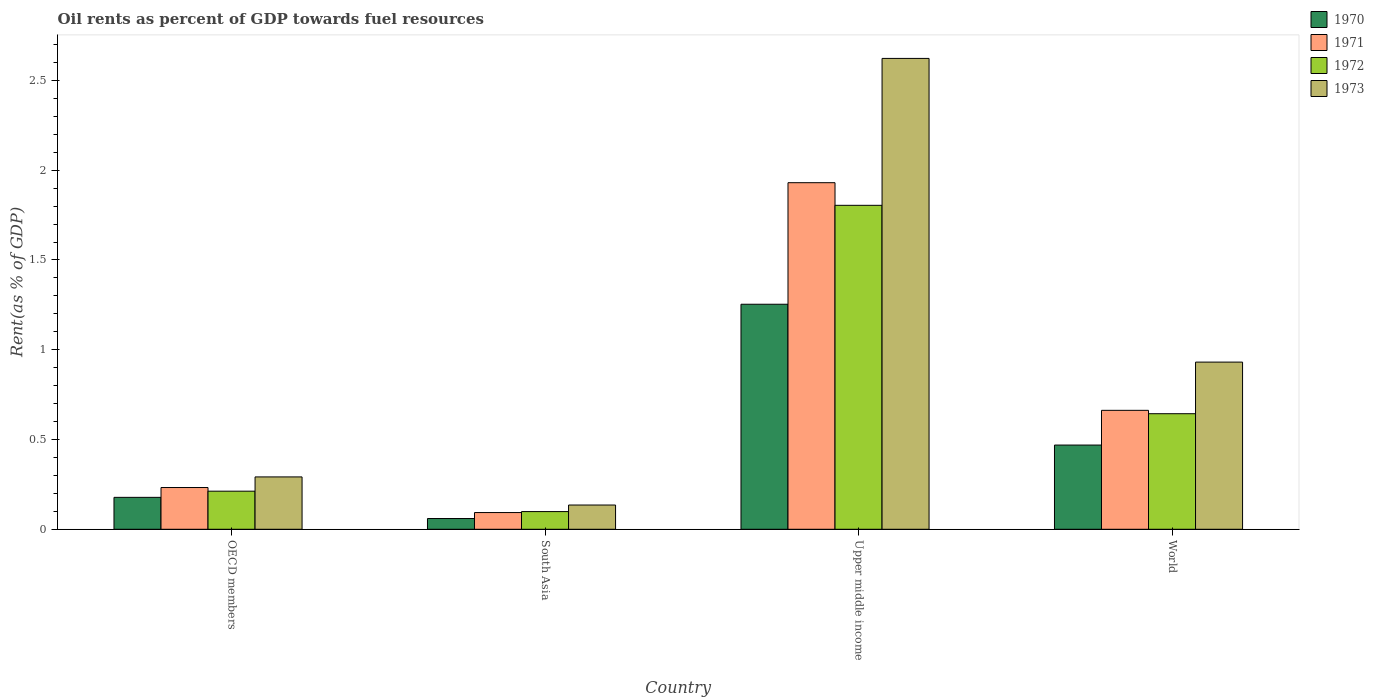How many different coloured bars are there?
Ensure brevity in your answer.  4. How many groups of bars are there?
Give a very brief answer. 4. In how many cases, is the number of bars for a given country not equal to the number of legend labels?
Give a very brief answer. 0. What is the oil rent in 1970 in Upper middle income?
Provide a succinct answer. 1.25. Across all countries, what is the maximum oil rent in 1973?
Ensure brevity in your answer.  2.62. Across all countries, what is the minimum oil rent in 1972?
Your answer should be very brief. 0.1. In which country was the oil rent in 1973 maximum?
Make the answer very short. Upper middle income. In which country was the oil rent in 1971 minimum?
Keep it short and to the point. South Asia. What is the total oil rent in 1973 in the graph?
Provide a short and direct response. 3.98. What is the difference between the oil rent in 1971 in OECD members and that in World?
Offer a very short reply. -0.43. What is the difference between the oil rent in 1973 in Upper middle income and the oil rent in 1971 in South Asia?
Offer a terse response. 2.53. What is the average oil rent in 1972 per country?
Your response must be concise. 0.69. What is the difference between the oil rent of/in 1971 and oil rent of/in 1972 in OECD members?
Make the answer very short. 0.02. What is the ratio of the oil rent in 1972 in OECD members to that in Upper middle income?
Ensure brevity in your answer.  0.12. What is the difference between the highest and the second highest oil rent in 1970?
Your response must be concise. -0.78. What is the difference between the highest and the lowest oil rent in 1970?
Your answer should be very brief. 1.19. In how many countries, is the oil rent in 1972 greater than the average oil rent in 1972 taken over all countries?
Ensure brevity in your answer.  1. What does the 2nd bar from the left in Upper middle income represents?
Provide a succinct answer. 1971. Is it the case that in every country, the sum of the oil rent in 1972 and oil rent in 1971 is greater than the oil rent in 1970?
Your response must be concise. Yes. Are all the bars in the graph horizontal?
Your answer should be compact. No. What is the difference between two consecutive major ticks on the Y-axis?
Provide a succinct answer. 0.5. Does the graph contain grids?
Your response must be concise. No. How many legend labels are there?
Offer a very short reply. 4. How are the legend labels stacked?
Your response must be concise. Vertical. What is the title of the graph?
Your answer should be very brief. Oil rents as percent of GDP towards fuel resources. What is the label or title of the Y-axis?
Make the answer very short. Rent(as % of GDP). What is the Rent(as % of GDP) in 1970 in OECD members?
Make the answer very short. 0.18. What is the Rent(as % of GDP) of 1971 in OECD members?
Offer a terse response. 0.23. What is the Rent(as % of GDP) of 1972 in OECD members?
Make the answer very short. 0.21. What is the Rent(as % of GDP) in 1973 in OECD members?
Give a very brief answer. 0.29. What is the Rent(as % of GDP) in 1970 in South Asia?
Make the answer very short. 0.06. What is the Rent(as % of GDP) of 1971 in South Asia?
Your answer should be very brief. 0.09. What is the Rent(as % of GDP) of 1972 in South Asia?
Your answer should be compact. 0.1. What is the Rent(as % of GDP) in 1973 in South Asia?
Your answer should be very brief. 0.14. What is the Rent(as % of GDP) in 1970 in Upper middle income?
Offer a very short reply. 1.25. What is the Rent(as % of GDP) in 1971 in Upper middle income?
Ensure brevity in your answer.  1.93. What is the Rent(as % of GDP) in 1972 in Upper middle income?
Provide a short and direct response. 1.8. What is the Rent(as % of GDP) in 1973 in Upper middle income?
Make the answer very short. 2.62. What is the Rent(as % of GDP) of 1970 in World?
Provide a succinct answer. 0.47. What is the Rent(as % of GDP) of 1971 in World?
Offer a very short reply. 0.66. What is the Rent(as % of GDP) of 1972 in World?
Offer a very short reply. 0.64. What is the Rent(as % of GDP) in 1973 in World?
Keep it short and to the point. 0.93. Across all countries, what is the maximum Rent(as % of GDP) in 1970?
Provide a short and direct response. 1.25. Across all countries, what is the maximum Rent(as % of GDP) of 1971?
Your answer should be compact. 1.93. Across all countries, what is the maximum Rent(as % of GDP) in 1972?
Offer a very short reply. 1.8. Across all countries, what is the maximum Rent(as % of GDP) in 1973?
Provide a succinct answer. 2.62. Across all countries, what is the minimum Rent(as % of GDP) of 1970?
Offer a terse response. 0.06. Across all countries, what is the minimum Rent(as % of GDP) in 1971?
Provide a short and direct response. 0.09. Across all countries, what is the minimum Rent(as % of GDP) of 1972?
Keep it short and to the point. 0.1. Across all countries, what is the minimum Rent(as % of GDP) of 1973?
Offer a terse response. 0.14. What is the total Rent(as % of GDP) in 1970 in the graph?
Give a very brief answer. 1.96. What is the total Rent(as % of GDP) of 1971 in the graph?
Keep it short and to the point. 2.92. What is the total Rent(as % of GDP) in 1972 in the graph?
Make the answer very short. 2.76. What is the total Rent(as % of GDP) of 1973 in the graph?
Give a very brief answer. 3.98. What is the difference between the Rent(as % of GDP) in 1970 in OECD members and that in South Asia?
Provide a short and direct response. 0.12. What is the difference between the Rent(as % of GDP) of 1971 in OECD members and that in South Asia?
Keep it short and to the point. 0.14. What is the difference between the Rent(as % of GDP) in 1972 in OECD members and that in South Asia?
Your response must be concise. 0.11. What is the difference between the Rent(as % of GDP) in 1973 in OECD members and that in South Asia?
Offer a terse response. 0.16. What is the difference between the Rent(as % of GDP) in 1970 in OECD members and that in Upper middle income?
Keep it short and to the point. -1.08. What is the difference between the Rent(as % of GDP) of 1971 in OECD members and that in Upper middle income?
Provide a succinct answer. -1.7. What is the difference between the Rent(as % of GDP) in 1972 in OECD members and that in Upper middle income?
Your answer should be very brief. -1.59. What is the difference between the Rent(as % of GDP) of 1973 in OECD members and that in Upper middle income?
Ensure brevity in your answer.  -2.33. What is the difference between the Rent(as % of GDP) in 1970 in OECD members and that in World?
Ensure brevity in your answer.  -0.29. What is the difference between the Rent(as % of GDP) of 1971 in OECD members and that in World?
Give a very brief answer. -0.43. What is the difference between the Rent(as % of GDP) of 1972 in OECD members and that in World?
Your answer should be compact. -0.43. What is the difference between the Rent(as % of GDP) in 1973 in OECD members and that in World?
Provide a short and direct response. -0.64. What is the difference between the Rent(as % of GDP) of 1970 in South Asia and that in Upper middle income?
Give a very brief answer. -1.19. What is the difference between the Rent(as % of GDP) in 1971 in South Asia and that in Upper middle income?
Your answer should be very brief. -1.84. What is the difference between the Rent(as % of GDP) of 1972 in South Asia and that in Upper middle income?
Make the answer very short. -1.71. What is the difference between the Rent(as % of GDP) in 1973 in South Asia and that in Upper middle income?
Keep it short and to the point. -2.49. What is the difference between the Rent(as % of GDP) of 1970 in South Asia and that in World?
Keep it short and to the point. -0.41. What is the difference between the Rent(as % of GDP) in 1971 in South Asia and that in World?
Give a very brief answer. -0.57. What is the difference between the Rent(as % of GDP) in 1972 in South Asia and that in World?
Provide a short and direct response. -0.55. What is the difference between the Rent(as % of GDP) of 1973 in South Asia and that in World?
Offer a terse response. -0.8. What is the difference between the Rent(as % of GDP) of 1970 in Upper middle income and that in World?
Your response must be concise. 0.78. What is the difference between the Rent(as % of GDP) of 1971 in Upper middle income and that in World?
Offer a very short reply. 1.27. What is the difference between the Rent(as % of GDP) in 1972 in Upper middle income and that in World?
Your response must be concise. 1.16. What is the difference between the Rent(as % of GDP) of 1973 in Upper middle income and that in World?
Provide a short and direct response. 1.69. What is the difference between the Rent(as % of GDP) in 1970 in OECD members and the Rent(as % of GDP) in 1971 in South Asia?
Give a very brief answer. 0.08. What is the difference between the Rent(as % of GDP) in 1970 in OECD members and the Rent(as % of GDP) in 1972 in South Asia?
Your answer should be compact. 0.08. What is the difference between the Rent(as % of GDP) in 1970 in OECD members and the Rent(as % of GDP) in 1973 in South Asia?
Ensure brevity in your answer.  0.04. What is the difference between the Rent(as % of GDP) of 1971 in OECD members and the Rent(as % of GDP) of 1972 in South Asia?
Provide a succinct answer. 0.13. What is the difference between the Rent(as % of GDP) of 1971 in OECD members and the Rent(as % of GDP) of 1973 in South Asia?
Provide a succinct answer. 0.1. What is the difference between the Rent(as % of GDP) of 1972 in OECD members and the Rent(as % of GDP) of 1973 in South Asia?
Keep it short and to the point. 0.08. What is the difference between the Rent(as % of GDP) in 1970 in OECD members and the Rent(as % of GDP) in 1971 in Upper middle income?
Provide a succinct answer. -1.75. What is the difference between the Rent(as % of GDP) in 1970 in OECD members and the Rent(as % of GDP) in 1972 in Upper middle income?
Provide a succinct answer. -1.63. What is the difference between the Rent(as % of GDP) in 1970 in OECD members and the Rent(as % of GDP) in 1973 in Upper middle income?
Your response must be concise. -2.44. What is the difference between the Rent(as % of GDP) of 1971 in OECD members and the Rent(as % of GDP) of 1972 in Upper middle income?
Your response must be concise. -1.57. What is the difference between the Rent(as % of GDP) of 1971 in OECD members and the Rent(as % of GDP) of 1973 in Upper middle income?
Keep it short and to the point. -2.39. What is the difference between the Rent(as % of GDP) in 1972 in OECD members and the Rent(as % of GDP) in 1973 in Upper middle income?
Provide a short and direct response. -2.41. What is the difference between the Rent(as % of GDP) of 1970 in OECD members and the Rent(as % of GDP) of 1971 in World?
Your response must be concise. -0.48. What is the difference between the Rent(as % of GDP) in 1970 in OECD members and the Rent(as % of GDP) in 1972 in World?
Keep it short and to the point. -0.47. What is the difference between the Rent(as % of GDP) of 1970 in OECD members and the Rent(as % of GDP) of 1973 in World?
Offer a very short reply. -0.75. What is the difference between the Rent(as % of GDP) in 1971 in OECD members and the Rent(as % of GDP) in 1972 in World?
Give a very brief answer. -0.41. What is the difference between the Rent(as % of GDP) of 1971 in OECD members and the Rent(as % of GDP) of 1973 in World?
Ensure brevity in your answer.  -0.7. What is the difference between the Rent(as % of GDP) of 1972 in OECD members and the Rent(as % of GDP) of 1973 in World?
Provide a short and direct response. -0.72. What is the difference between the Rent(as % of GDP) of 1970 in South Asia and the Rent(as % of GDP) of 1971 in Upper middle income?
Your answer should be very brief. -1.87. What is the difference between the Rent(as % of GDP) of 1970 in South Asia and the Rent(as % of GDP) of 1972 in Upper middle income?
Keep it short and to the point. -1.74. What is the difference between the Rent(as % of GDP) of 1970 in South Asia and the Rent(as % of GDP) of 1973 in Upper middle income?
Make the answer very short. -2.56. What is the difference between the Rent(as % of GDP) of 1971 in South Asia and the Rent(as % of GDP) of 1972 in Upper middle income?
Your answer should be very brief. -1.71. What is the difference between the Rent(as % of GDP) in 1971 in South Asia and the Rent(as % of GDP) in 1973 in Upper middle income?
Offer a very short reply. -2.53. What is the difference between the Rent(as % of GDP) in 1972 in South Asia and the Rent(as % of GDP) in 1973 in Upper middle income?
Your answer should be very brief. -2.52. What is the difference between the Rent(as % of GDP) in 1970 in South Asia and the Rent(as % of GDP) in 1971 in World?
Your answer should be compact. -0.6. What is the difference between the Rent(as % of GDP) in 1970 in South Asia and the Rent(as % of GDP) in 1972 in World?
Ensure brevity in your answer.  -0.58. What is the difference between the Rent(as % of GDP) of 1970 in South Asia and the Rent(as % of GDP) of 1973 in World?
Your answer should be very brief. -0.87. What is the difference between the Rent(as % of GDP) in 1971 in South Asia and the Rent(as % of GDP) in 1972 in World?
Your answer should be very brief. -0.55. What is the difference between the Rent(as % of GDP) of 1971 in South Asia and the Rent(as % of GDP) of 1973 in World?
Make the answer very short. -0.84. What is the difference between the Rent(as % of GDP) in 1972 in South Asia and the Rent(as % of GDP) in 1973 in World?
Provide a short and direct response. -0.83. What is the difference between the Rent(as % of GDP) in 1970 in Upper middle income and the Rent(as % of GDP) in 1971 in World?
Your answer should be very brief. 0.59. What is the difference between the Rent(as % of GDP) of 1970 in Upper middle income and the Rent(as % of GDP) of 1972 in World?
Provide a succinct answer. 0.61. What is the difference between the Rent(as % of GDP) in 1970 in Upper middle income and the Rent(as % of GDP) in 1973 in World?
Provide a short and direct response. 0.32. What is the difference between the Rent(as % of GDP) of 1971 in Upper middle income and the Rent(as % of GDP) of 1972 in World?
Give a very brief answer. 1.29. What is the difference between the Rent(as % of GDP) of 1971 in Upper middle income and the Rent(as % of GDP) of 1973 in World?
Provide a succinct answer. 1. What is the difference between the Rent(as % of GDP) of 1972 in Upper middle income and the Rent(as % of GDP) of 1973 in World?
Keep it short and to the point. 0.87. What is the average Rent(as % of GDP) of 1970 per country?
Provide a short and direct response. 0.49. What is the average Rent(as % of GDP) of 1971 per country?
Offer a very short reply. 0.73. What is the average Rent(as % of GDP) in 1972 per country?
Offer a very short reply. 0.69. What is the difference between the Rent(as % of GDP) of 1970 and Rent(as % of GDP) of 1971 in OECD members?
Offer a terse response. -0.05. What is the difference between the Rent(as % of GDP) in 1970 and Rent(as % of GDP) in 1972 in OECD members?
Your answer should be very brief. -0.03. What is the difference between the Rent(as % of GDP) in 1970 and Rent(as % of GDP) in 1973 in OECD members?
Provide a short and direct response. -0.11. What is the difference between the Rent(as % of GDP) of 1971 and Rent(as % of GDP) of 1972 in OECD members?
Provide a succinct answer. 0.02. What is the difference between the Rent(as % of GDP) of 1971 and Rent(as % of GDP) of 1973 in OECD members?
Provide a short and direct response. -0.06. What is the difference between the Rent(as % of GDP) in 1972 and Rent(as % of GDP) in 1973 in OECD members?
Ensure brevity in your answer.  -0.08. What is the difference between the Rent(as % of GDP) in 1970 and Rent(as % of GDP) in 1971 in South Asia?
Offer a very short reply. -0.03. What is the difference between the Rent(as % of GDP) of 1970 and Rent(as % of GDP) of 1972 in South Asia?
Provide a succinct answer. -0.04. What is the difference between the Rent(as % of GDP) of 1970 and Rent(as % of GDP) of 1973 in South Asia?
Ensure brevity in your answer.  -0.08. What is the difference between the Rent(as % of GDP) in 1971 and Rent(as % of GDP) in 1972 in South Asia?
Offer a very short reply. -0.01. What is the difference between the Rent(as % of GDP) of 1971 and Rent(as % of GDP) of 1973 in South Asia?
Your response must be concise. -0.04. What is the difference between the Rent(as % of GDP) of 1972 and Rent(as % of GDP) of 1973 in South Asia?
Offer a terse response. -0.04. What is the difference between the Rent(as % of GDP) in 1970 and Rent(as % of GDP) in 1971 in Upper middle income?
Your response must be concise. -0.68. What is the difference between the Rent(as % of GDP) in 1970 and Rent(as % of GDP) in 1972 in Upper middle income?
Ensure brevity in your answer.  -0.55. What is the difference between the Rent(as % of GDP) of 1970 and Rent(as % of GDP) of 1973 in Upper middle income?
Make the answer very short. -1.37. What is the difference between the Rent(as % of GDP) in 1971 and Rent(as % of GDP) in 1972 in Upper middle income?
Provide a short and direct response. 0.13. What is the difference between the Rent(as % of GDP) of 1971 and Rent(as % of GDP) of 1973 in Upper middle income?
Offer a terse response. -0.69. What is the difference between the Rent(as % of GDP) of 1972 and Rent(as % of GDP) of 1973 in Upper middle income?
Give a very brief answer. -0.82. What is the difference between the Rent(as % of GDP) in 1970 and Rent(as % of GDP) in 1971 in World?
Your response must be concise. -0.19. What is the difference between the Rent(as % of GDP) in 1970 and Rent(as % of GDP) in 1972 in World?
Your answer should be compact. -0.17. What is the difference between the Rent(as % of GDP) in 1970 and Rent(as % of GDP) in 1973 in World?
Ensure brevity in your answer.  -0.46. What is the difference between the Rent(as % of GDP) of 1971 and Rent(as % of GDP) of 1972 in World?
Keep it short and to the point. 0.02. What is the difference between the Rent(as % of GDP) in 1971 and Rent(as % of GDP) in 1973 in World?
Give a very brief answer. -0.27. What is the difference between the Rent(as % of GDP) in 1972 and Rent(as % of GDP) in 1973 in World?
Keep it short and to the point. -0.29. What is the ratio of the Rent(as % of GDP) of 1970 in OECD members to that in South Asia?
Give a very brief answer. 2.97. What is the ratio of the Rent(as % of GDP) in 1971 in OECD members to that in South Asia?
Offer a terse response. 2.5. What is the ratio of the Rent(as % of GDP) of 1972 in OECD members to that in South Asia?
Make the answer very short. 2.15. What is the ratio of the Rent(as % of GDP) in 1973 in OECD members to that in South Asia?
Provide a short and direct response. 2.16. What is the ratio of the Rent(as % of GDP) of 1970 in OECD members to that in Upper middle income?
Give a very brief answer. 0.14. What is the ratio of the Rent(as % of GDP) in 1971 in OECD members to that in Upper middle income?
Offer a terse response. 0.12. What is the ratio of the Rent(as % of GDP) in 1972 in OECD members to that in Upper middle income?
Offer a terse response. 0.12. What is the ratio of the Rent(as % of GDP) in 1973 in OECD members to that in Upper middle income?
Make the answer very short. 0.11. What is the ratio of the Rent(as % of GDP) in 1970 in OECD members to that in World?
Provide a short and direct response. 0.38. What is the ratio of the Rent(as % of GDP) of 1971 in OECD members to that in World?
Make the answer very short. 0.35. What is the ratio of the Rent(as % of GDP) in 1972 in OECD members to that in World?
Give a very brief answer. 0.33. What is the ratio of the Rent(as % of GDP) of 1973 in OECD members to that in World?
Make the answer very short. 0.31. What is the ratio of the Rent(as % of GDP) in 1970 in South Asia to that in Upper middle income?
Your answer should be compact. 0.05. What is the ratio of the Rent(as % of GDP) of 1971 in South Asia to that in Upper middle income?
Give a very brief answer. 0.05. What is the ratio of the Rent(as % of GDP) of 1972 in South Asia to that in Upper middle income?
Keep it short and to the point. 0.05. What is the ratio of the Rent(as % of GDP) of 1973 in South Asia to that in Upper middle income?
Offer a very short reply. 0.05. What is the ratio of the Rent(as % of GDP) of 1970 in South Asia to that in World?
Keep it short and to the point. 0.13. What is the ratio of the Rent(as % of GDP) of 1971 in South Asia to that in World?
Offer a very short reply. 0.14. What is the ratio of the Rent(as % of GDP) of 1972 in South Asia to that in World?
Your answer should be very brief. 0.15. What is the ratio of the Rent(as % of GDP) in 1973 in South Asia to that in World?
Provide a succinct answer. 0.14. What is the ratio of the Rent(as % of GDP) of 1970 in Upper middle income to that in World?
Your answer should be very brief. 2.67. What is the ratio of the Rent(as % of GDP) of 1971 in Upper middle income to that in World?
Provide a short and direct response. 2.91. What is the ratio of the Rent(as % of GDP) of 1972 in Upper middle income to that in World?
Your answer should be very brief. 2.8. What is the ratio of the Rent(as % of GDP) in 1973 in Upper middle income to that in World?
Ensure brevity in your answer.  2.82. What is the difference between the highest and the second highest Rent(as % of GDP) of 1970?
Offer a terse response. 0.78. What is the difference between the highest and the second highest Rent(as % of GDP) of 1971?
Make the answer very short. 1.27. What is the difference between the highest and the second highest Rent(as % of GDP) in 1972?
Provide a succinct answer. 1.16. What is the difference between the highest and the second highest Rent(as % of GDP) in 1973?
Your answer should be compact. 1.69. What is the difference between the highest and the lowest Rent(as % of GDP) in 1970?
Give a very brief answer. 1.19. What is the difference between the highest and the lowest Rent(as % of GDP) in 1971?
Make the answer very short. 1.84. What is the difference between the highest and the lowest Rent(as % of GDP) in 1972?
Keep it short and to the point. 1.71. What is the difference between the highest and the lowest Rent(as % of GDP) in 1973?
Keep it short and to the point. 2.49. 